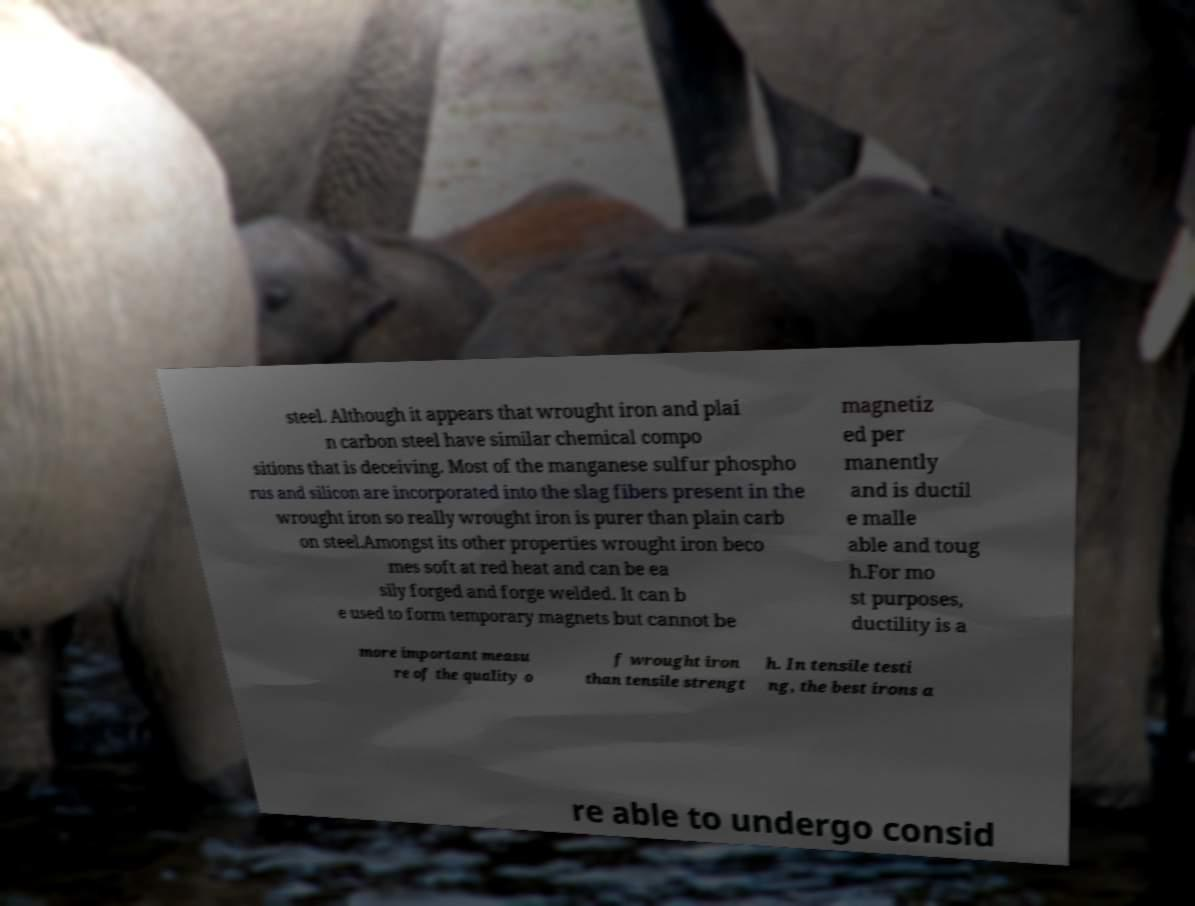Could you extract and type out the text from this image? steel. Although it appears that wrought iron and plai n carbon steel have similar chemical compo sitions that is deceiving. Most of the manganese sulfur phospho rus and silicon are incorporated into the slag fibers present in the wrought iron so really wrought iron is purer than plain carb on steel.Amongst its other properties wrought iron beco mes soft at red heat and can be ea sily forged and forge welded. It can b e used to form temporary magnets but cannot be magnetiz ed per manently and is ductil e malle able and toug h.For mo st purposes, ductility is a more important measu re of the quality o f wrought iron than tensile strengt h. In tensile testi ng, the best irons a re able to undergo consid 